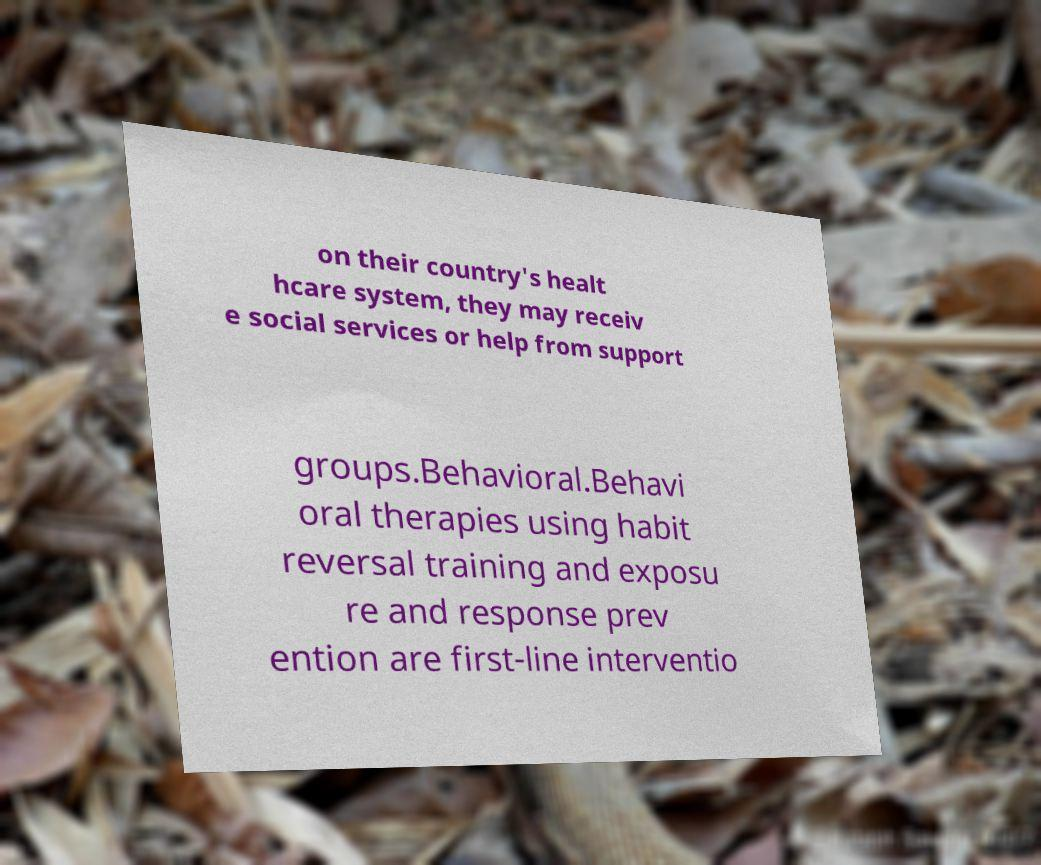Can you accurately transcribe the text from the provided image for me? on their country's healt hcare system, they may receiv e social services or help from support groups.Behavioral.Behavi oral therapies using habit reversal training and exposu re and response prev ention are first-line interventio 